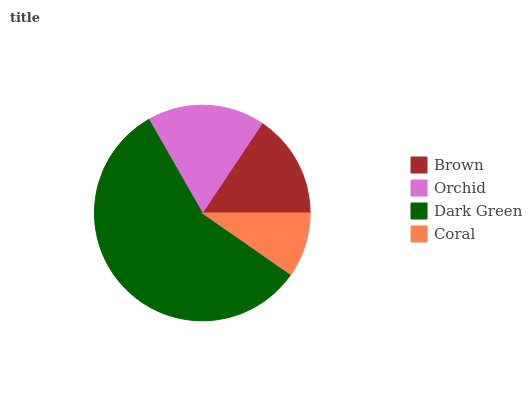Is Coral the minimum?
Answer yes or no. Yes. Is Dark Green the maximum?
Answer yes or no. Yes. Is Orchid the minimum?
Answer yes or no. No. Is Orchid the maximum?
Answer yes or no. No. Is Orchid greater than Brown?
Answer yes or no. Yes. Is Brown less than Orchid?
Answer yes or no. Yes. Is Brown greater than Orchid?
Answer yes or no. No. Is Orchid less than Brown?
Answer yes or no. No. Is Orchid the high median?
Answer yes or no. Yes. Is Brown the low median?
Answer yes or no. Yes. Is Dark Green the high median?
Answer yes or no. No. Is Coral the low median?
Answer yes or no. No. 